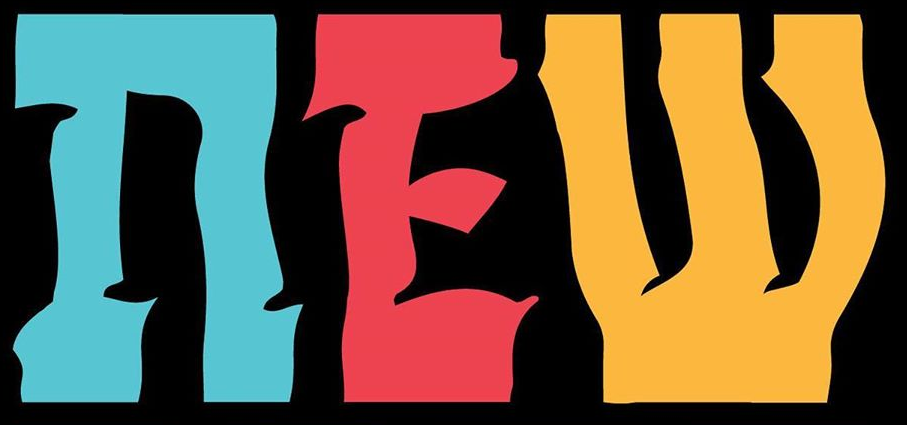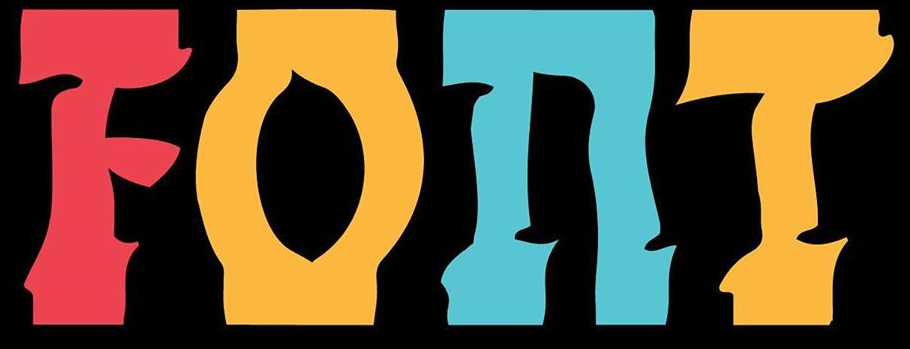What words are shown in these images in order, separated by a semicolon? nEW; FOnT 